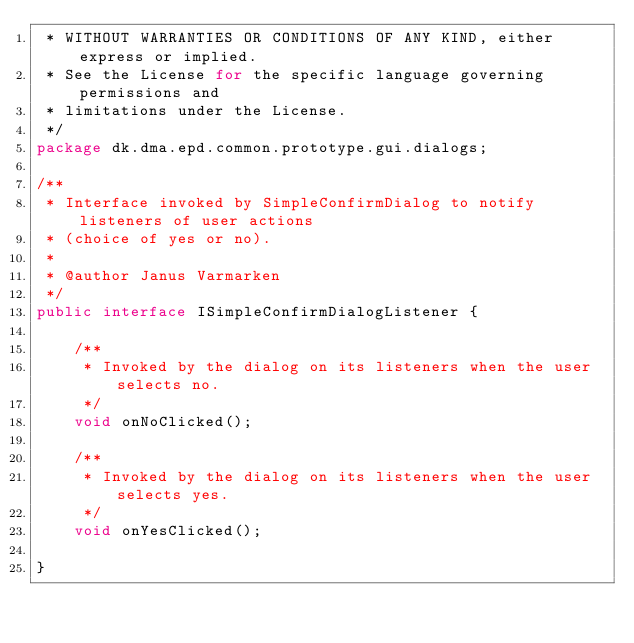<code> <loc_0><loc_0><loc_500><loc_500><_Java_> * WITHOUT WARRANTIES OR CONDITIONS OF ANY KIND, either express or implied.
 * See the License for the specific language governing permissions and
 * limitations under the License.
 */
package dk.dma.epd.common.prototype.gui.dialogs;

/**
 * Interface invoked by SimpleConfirmDialog to notify listeners of user actions
 * (choice of yes or no).
 * 
 * @author Janus Varmarken
 */
public interface ISimpleConfirmDialogListener {
    
    /**
     * Invoked by the dialog on its listeners when the user selects no.
     */
    void onNoClicked();
    
    /**
     * Invoked by the dialog on its listeners when the user selects yes.
     */
    void onYesClicked();
    
}
</code> 